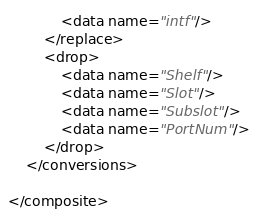Convert code to text. <code><loc_0><loc_0><loc_500><loc_500><_XML_>            <data name="intf"/>
        </replace>
        <drop>
            <data name="Shelf"/>
            <data name="Slot"/>
            <data name="Subslot"/>
            <data name="PortNum"/>
        </drop>
    </conversions>

</composite>
</code> 